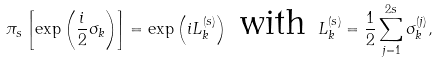<formula> <loc_0><loc_0><loc_500><loc_500>\pi _ { s } \left [ \exp \left ( \frac { i } { 2 } \sigma _ { k } \right ) \right ] = \exp \left ( i L _ { k } ^ { ( s ) } \right ) \ \text {with} \ L _ { k } ^ { ( s ) } = \frac { 1 } { 2 } \sum _ { j = 1 } ^ { 2 s } \sigma ^ { ( j ) } _ { k } ,</formula> 